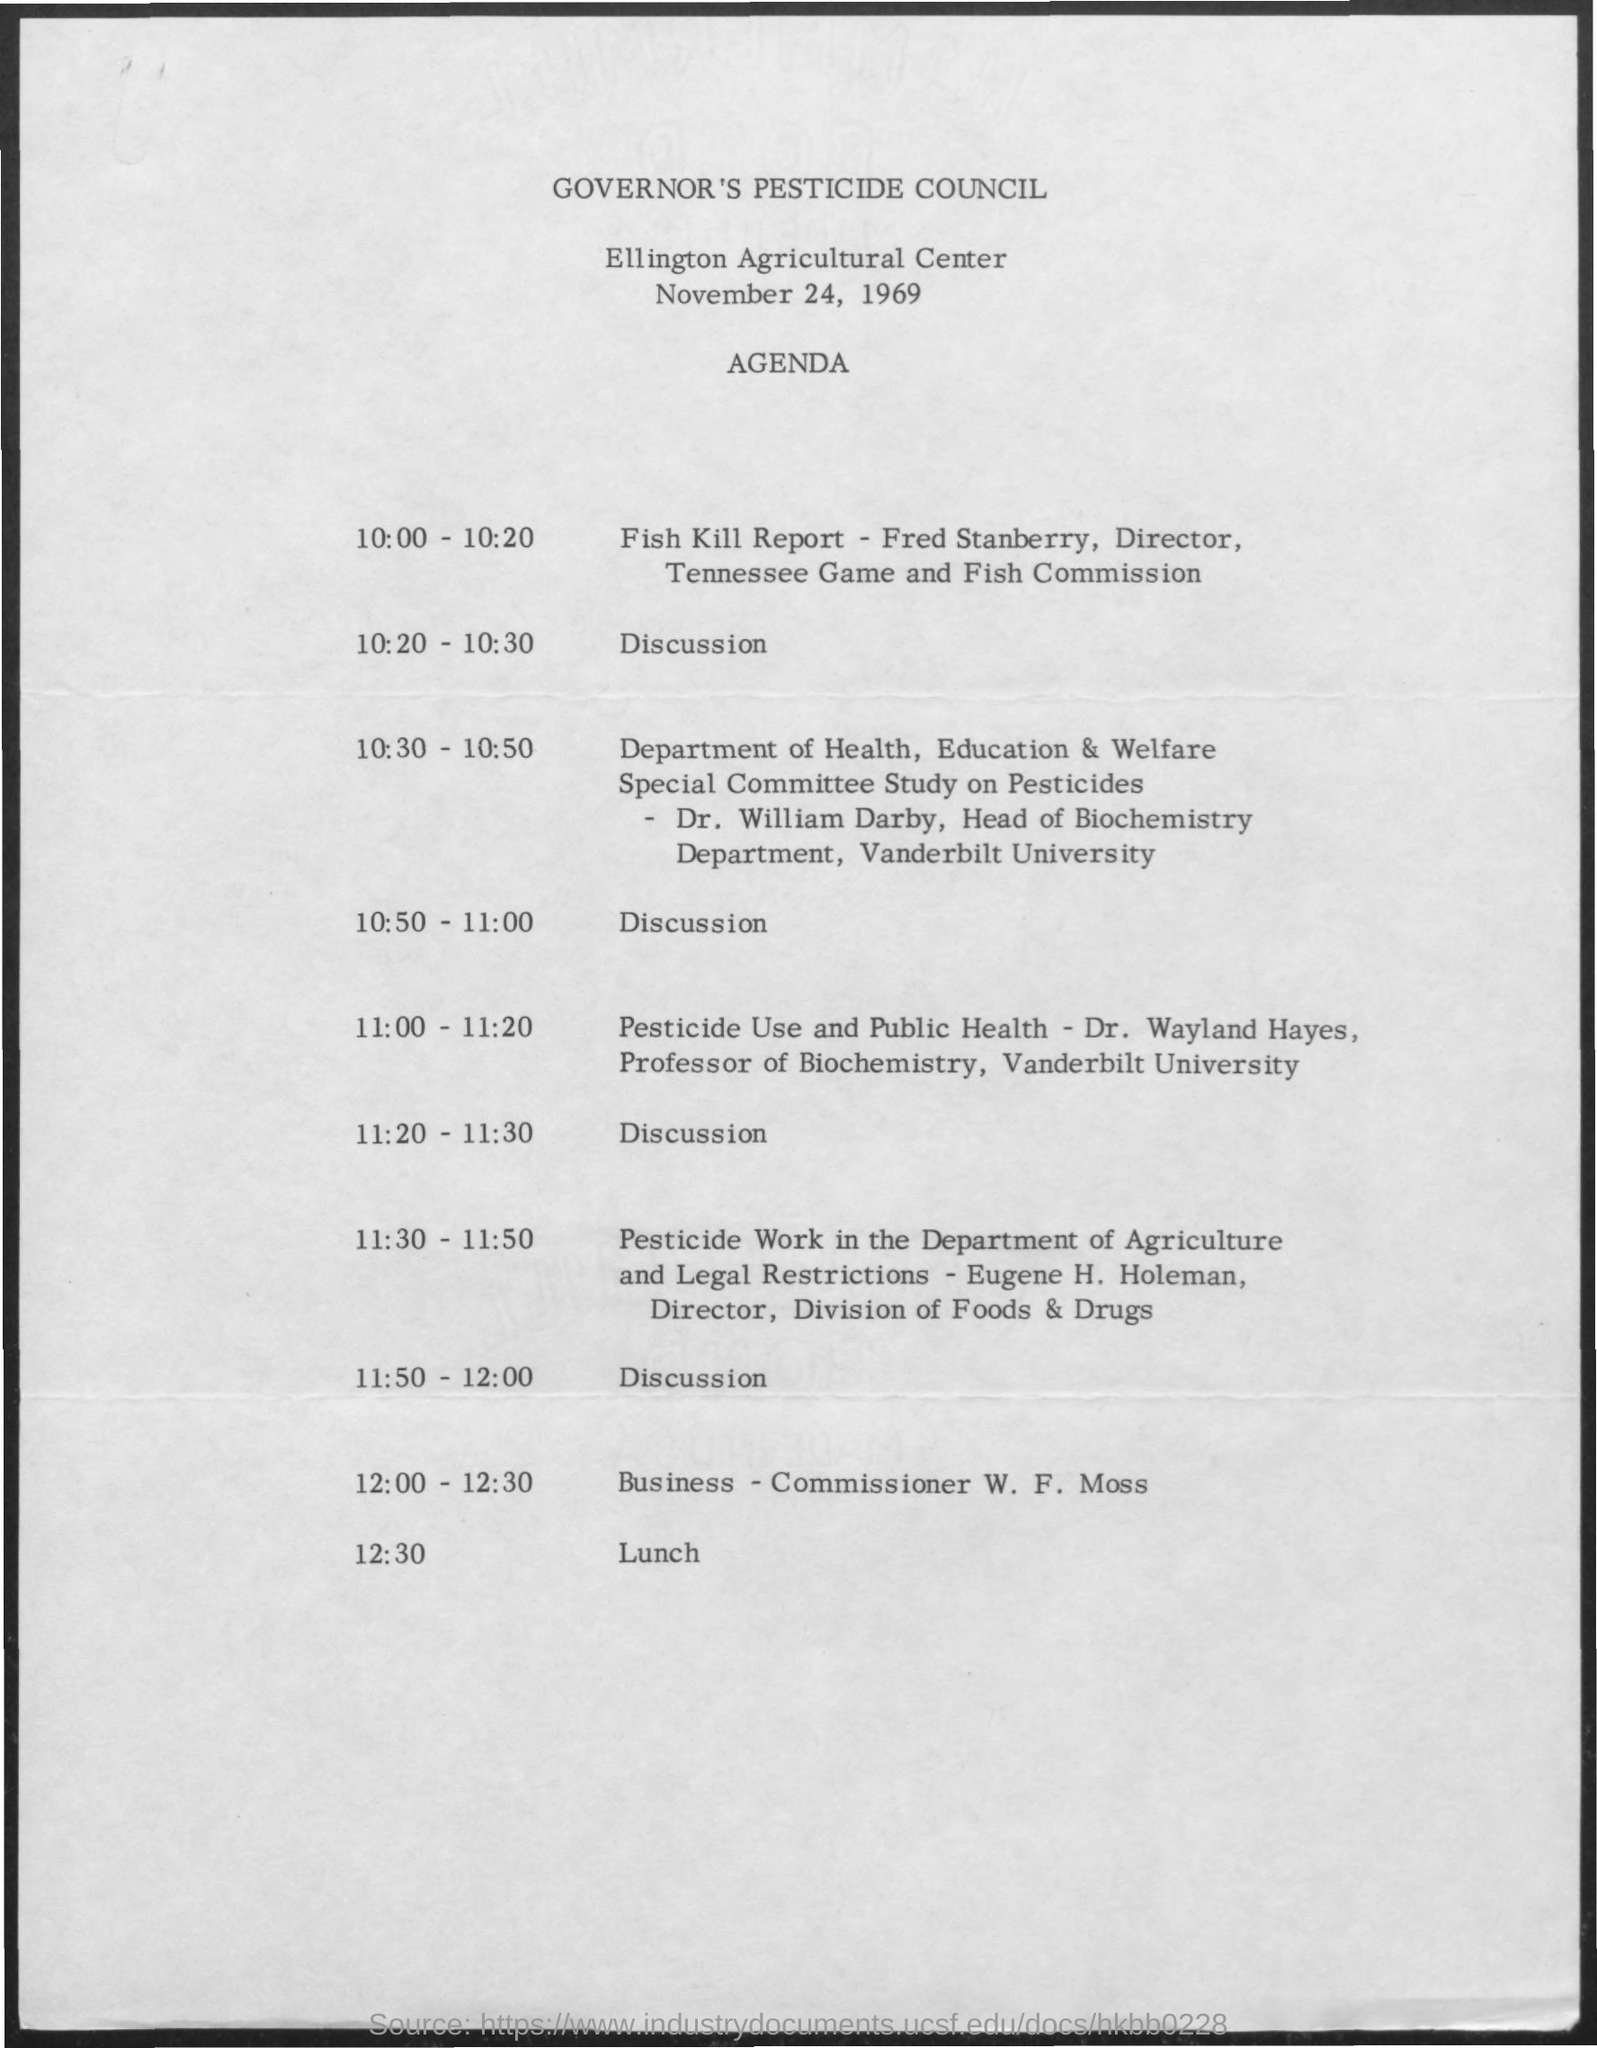Point out several critical features in this image. The fish kill report will be provided at 10:00 to 10:20. The council was held on November 24, 1969. At 12:30, lunch will be. 